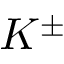<formula> <loc_0><loc_0><loc_500><loc_500>K ^ { \pm }</formula> 